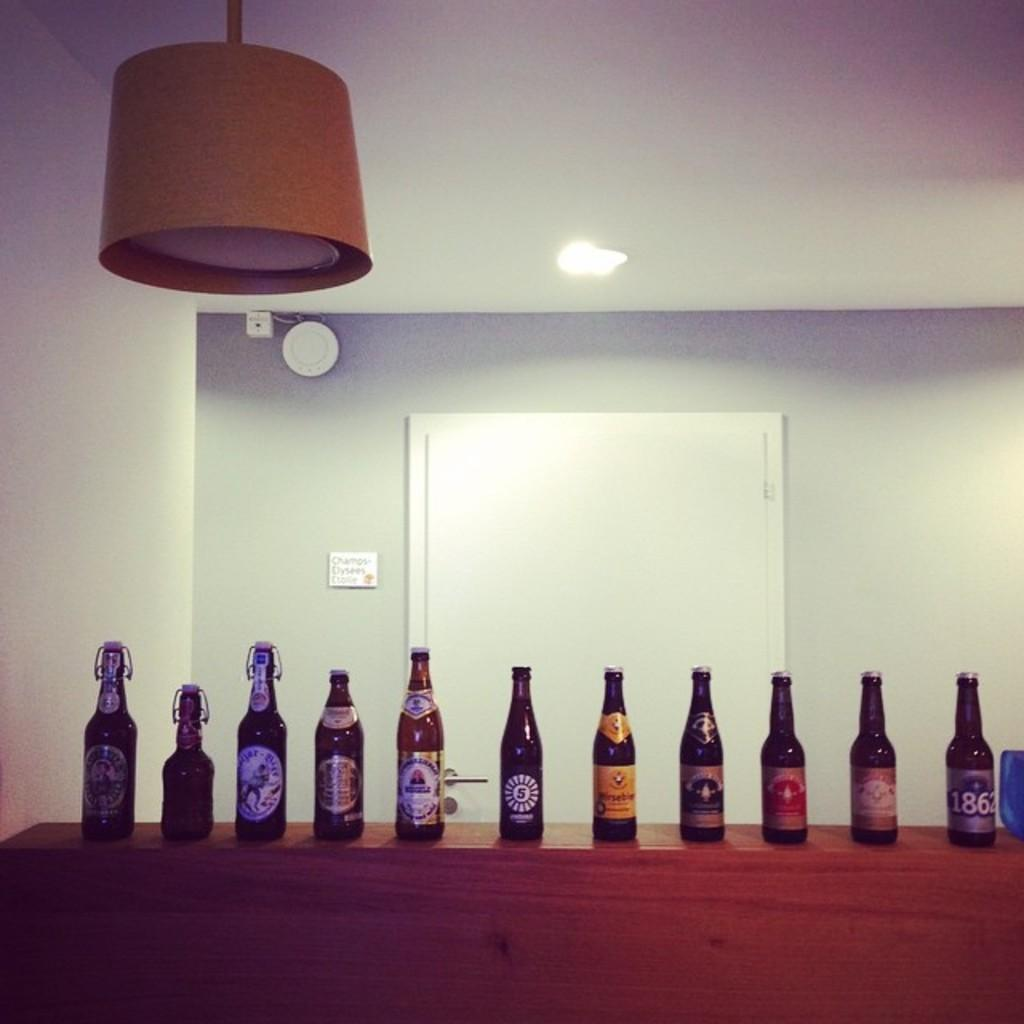<image>
Summarize the visual content of the image. Bottles of alcohol lined up on the shelf, the one on the end says 1862. 